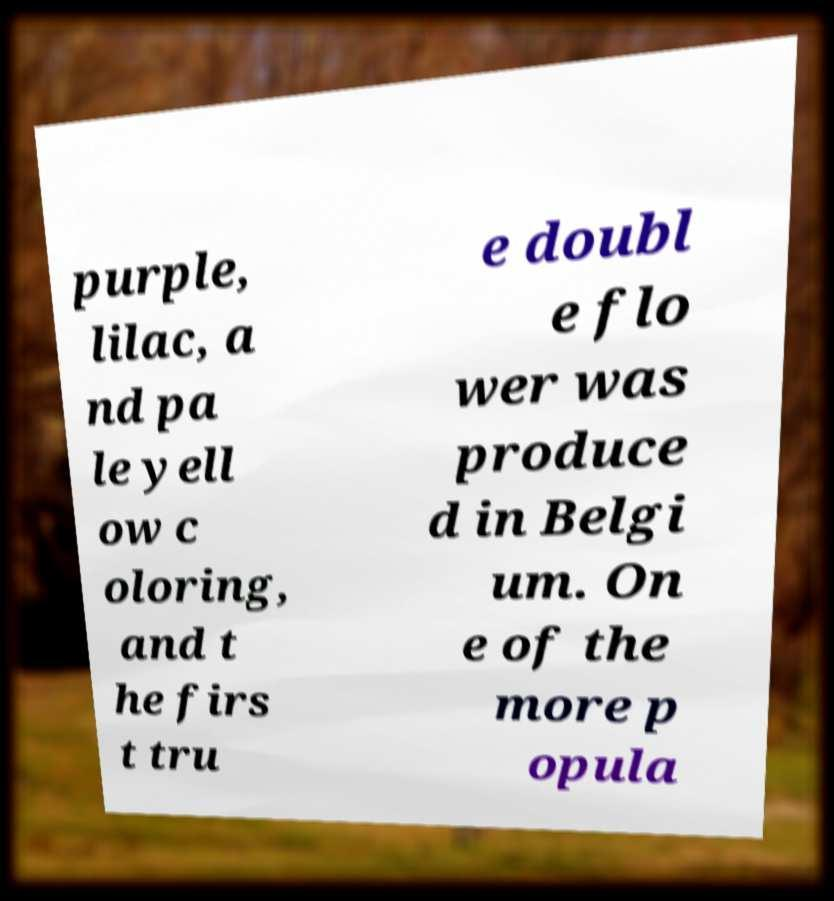For documentation purposes, I need the text within this image transcribed. Could you provide that? purple, lilac, a nd pa le yell ow c oloring, and t he firs t tru e doubl e flo wer was produce d in Belgi um. On e of the more p opula 